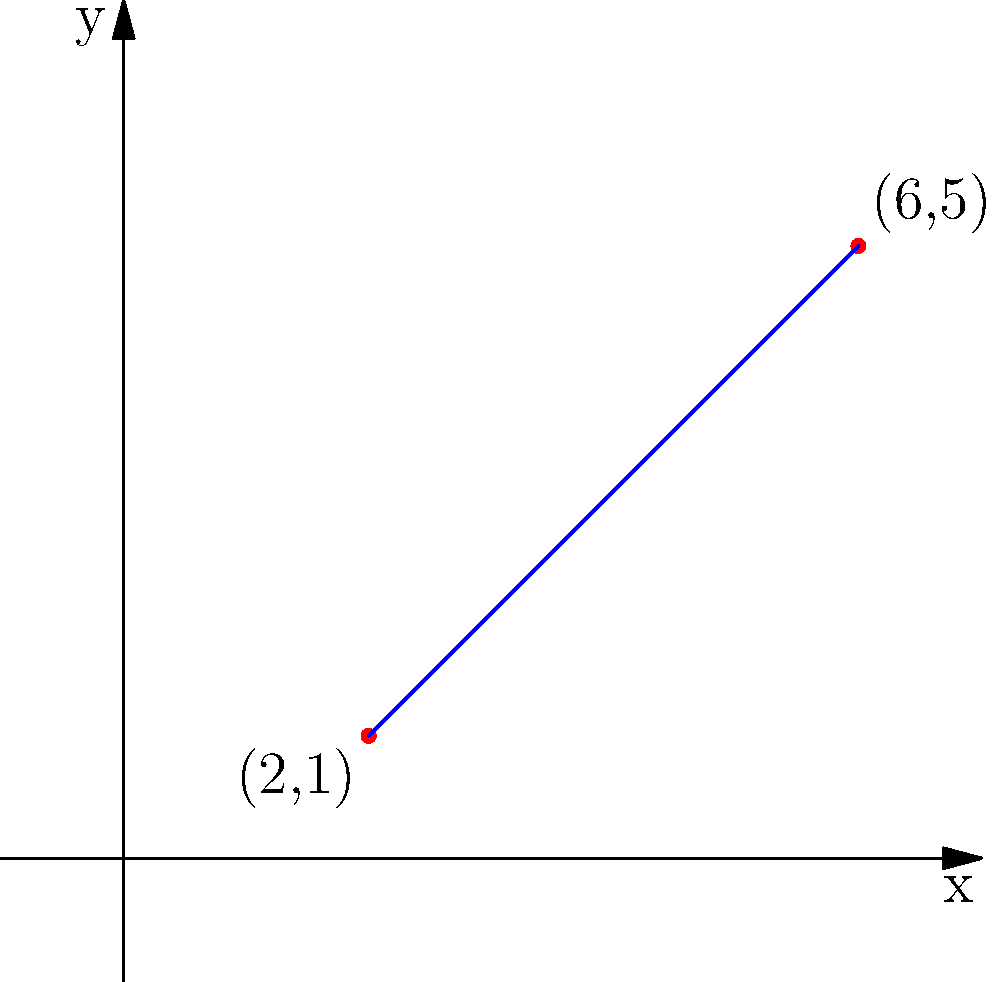Given two points on a coordinate plane, (2,1) and (6,5), calculate the slope of the line passing through these points. Express your answer as a fraction in its simplest form. To calculate the slope of a line given two points, we use the slope formula:

$$ m = \frac{y_2 - y_1}{x_2 - x_1} $$

Where $(x_1, y_1)$ is the first point and $(x_2, y_2)$ is the second point.

Step 1: Identify the coordinates
$(x_1, y_1) = (2, 1)$
$(x_2, y_2) = (6, 5)$

Step 2: Substitute the values into the slope formula
$$ m = \frac{5 - 1}{6 - 2} $$

Step 3: Simplify the numerator and denominator
$$ m = \frac{4}{4} $$

Step 4: Reduce the fraction to its simplest form
$$ m = 1 $$

Therefore, the slope of the line passing through the points (2,1) and (6,5) is 1.
Answer: $1$ 